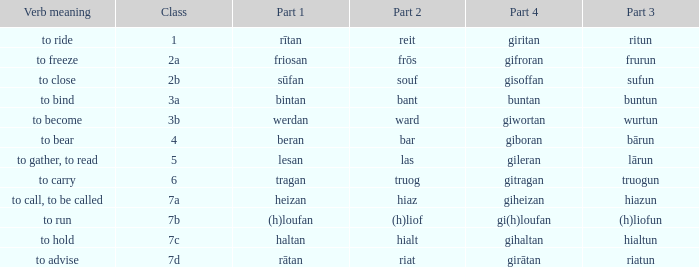What is the part 4 of the word with the part 1 "heizan"? Giheizan. 